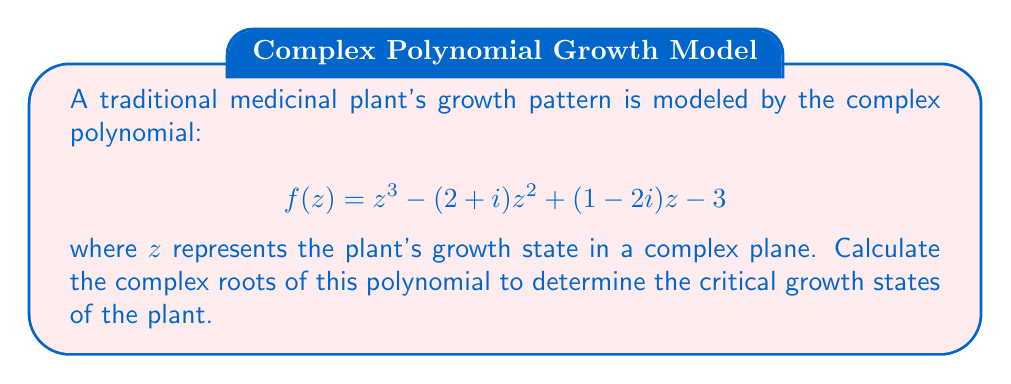Can you solve this math problem? To find the complex roots of the polynomial, we'll use the cubic formula:

1) First, we need to convert the polynomial to the standard form:
   $$z^3 + az^2 + bz + c = 0$$
   where $a = -(2+i)$, $b = 1-2i$, and $c = -3$

2) Calculate the following quantities:
   $$p = b - \frac{a^2}{3} = (1-2i) - \frac{(-2-i)^2}{3} = 1-2i - \frac{4+4i-1}{3} = -\frac{1}{3}-2i$$
   $$q = c + \frac{2a^3}{27} - \frac{ab}{3} = -3 + \frac{2(-2-i)^3}{27} - \frac{(-2-i)(1-2i)}{3}$$
   $$q = -3 + \frac{-16-24i+12i+i^3}{27} - \frac{-2+4i+i+2}{3} = -\frac{37}{9}-\frac{4}{3}i$$

3) Now, calculate the discriminant:
   $$D = (\frac{q}{2})^2 + (\frac{p}{3})^3$$
   $$D = (\frac{-37/9-4i/3}{2})^2 + (\frac{-1/3-2i}{3})^3$$

4) The roots are given by:
   $$z_k = -\frac{a}{3} + \sqrt[3]{-\frac{q}{2} + \sqrt{D}} + \sqrt[3]{-\frac{q}{2} - \sqrt{D}}$$
   where $k = 0, 1, 2$ and the cube roots are multiplied by $1, \omega, \omega^2$ respectively, with $\omega = e^{2\pi i/3}$

5) Calculate these values numerically to obtain the three complex roots.
Answer: $z_1 \approx 2.21 + 0.37i$, $z_2 \approx -0.10 + 1.31i$, $z_3 \approx -0.11 - 0.68i$ 